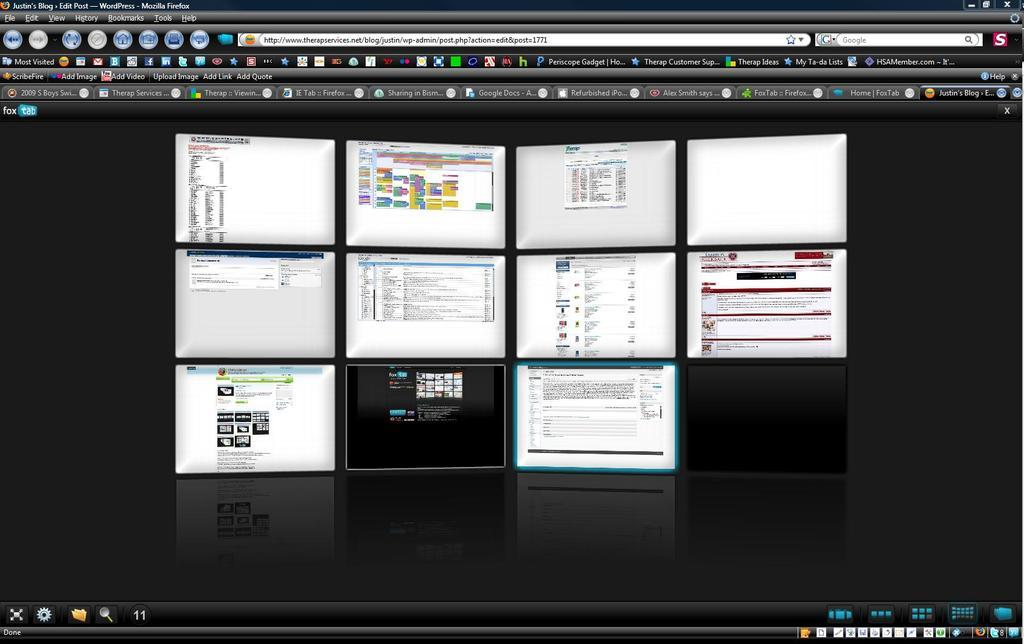Provide a one-sentence caption for the provided image. Multiple tabs are open on a computer screen such as ScribeFire. 